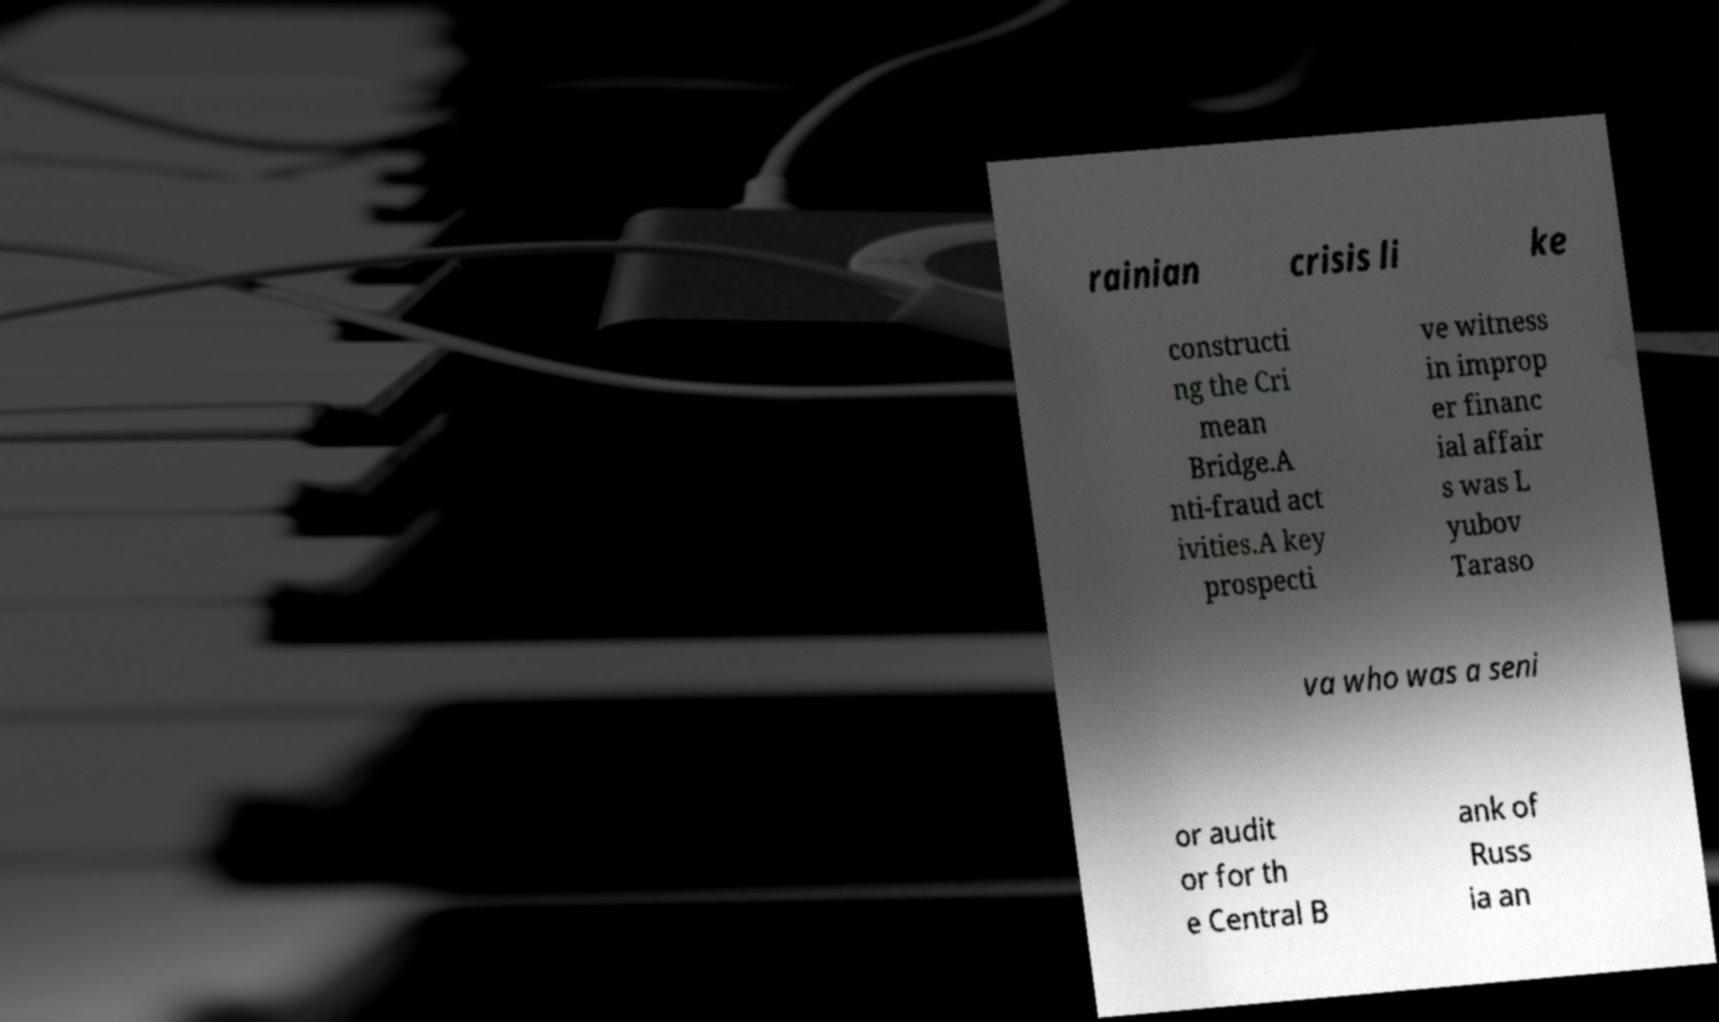Could you extract and type out the text from this image? rainian crisis li ke constructi ng the Cri mean Bridge.A nti-fraud act ivities.A key prospecti ve witness in improp er financ ial affair s was L yubov Taraso va who was a seni or audit or for th e Central B ank of Russ ia an 